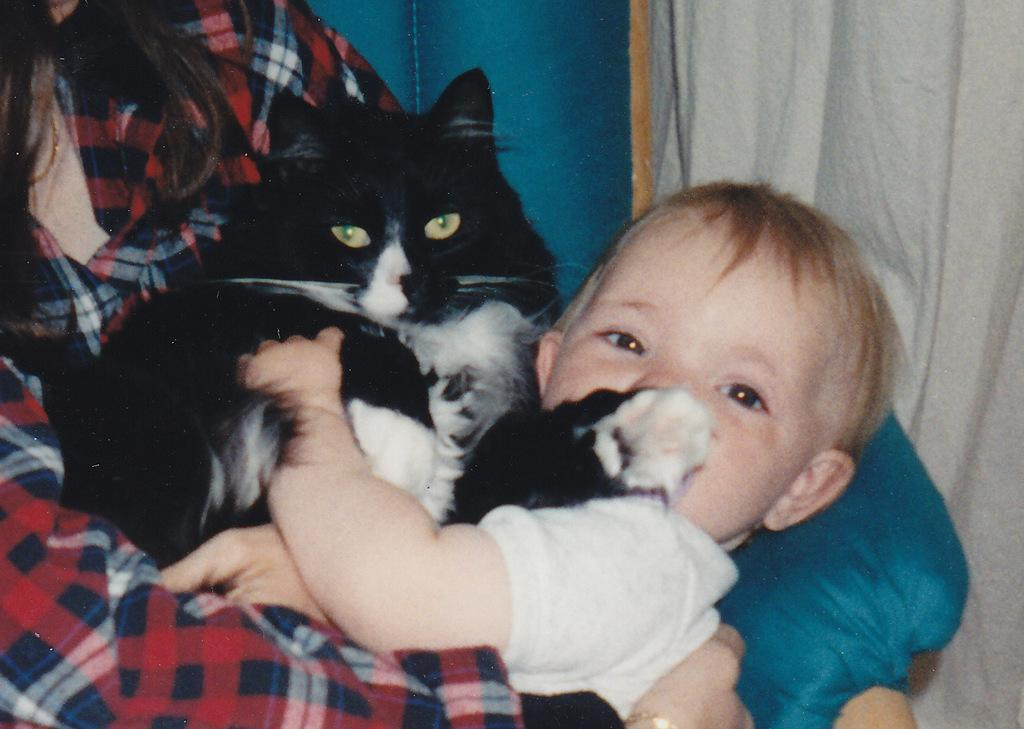What is the person in the image holding? The person is holding a cat in the image. What can be seen in the child's hands in the image? The child has their hands visible in the image. What type of fabric is present in the image? There is a curtain visible in the image. Where are the dinosaurs hiding in the image? There are no dinosaurs present in the image. What type of veil is covering the person's face in the image? There is no veil covering the person's face in the image; they are holding a cat. 